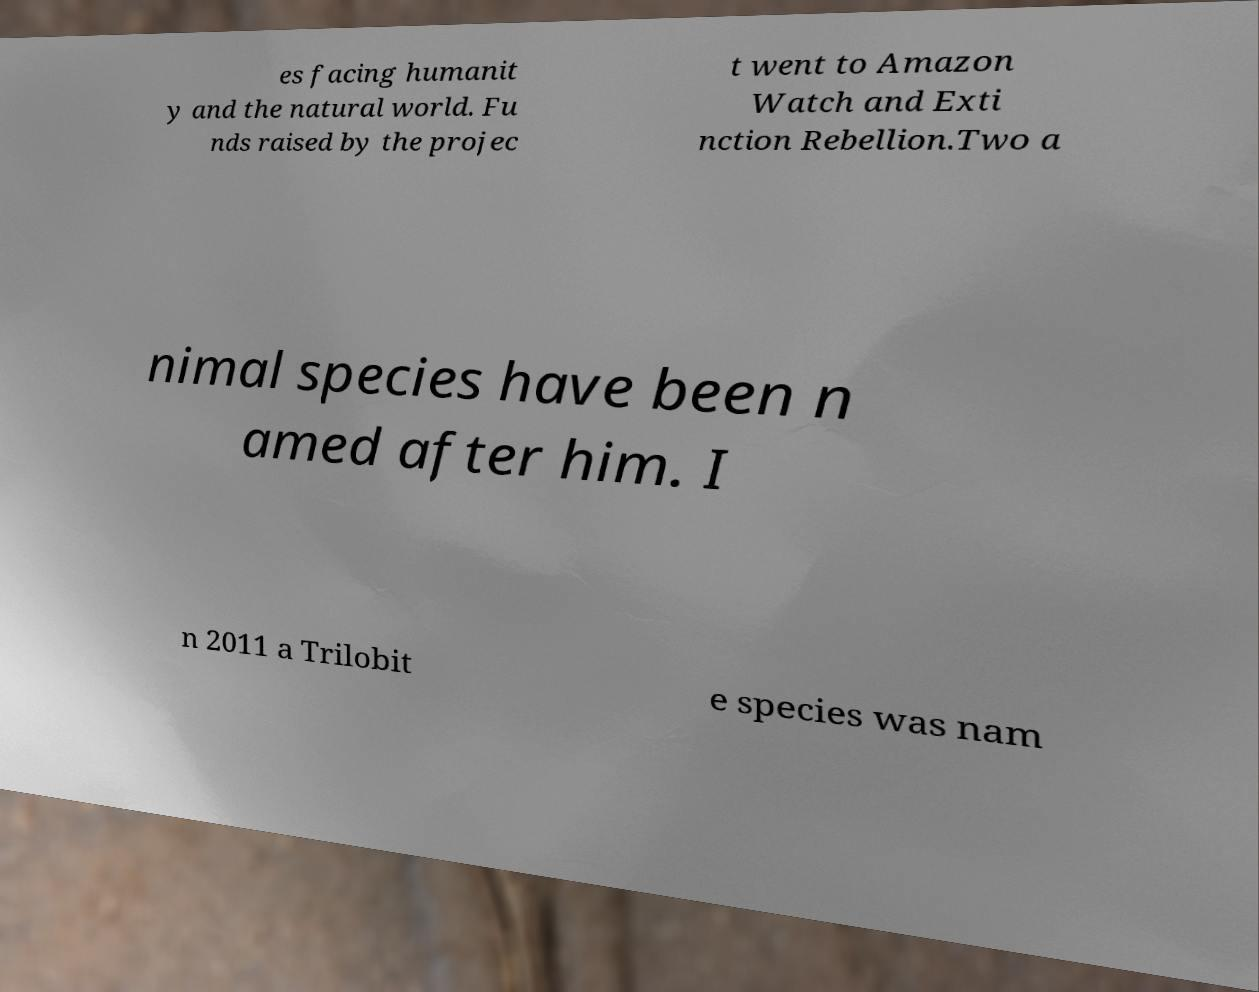Please read and relay the text visible in this image. What does it say? es facing humanit y and the natural world. Fu nds raised by the projec t went to Amazon Watch and Exti nction Rebellion.Two a nimal species have been n amed after him. I n 2011 a Trilobit e species was nam 